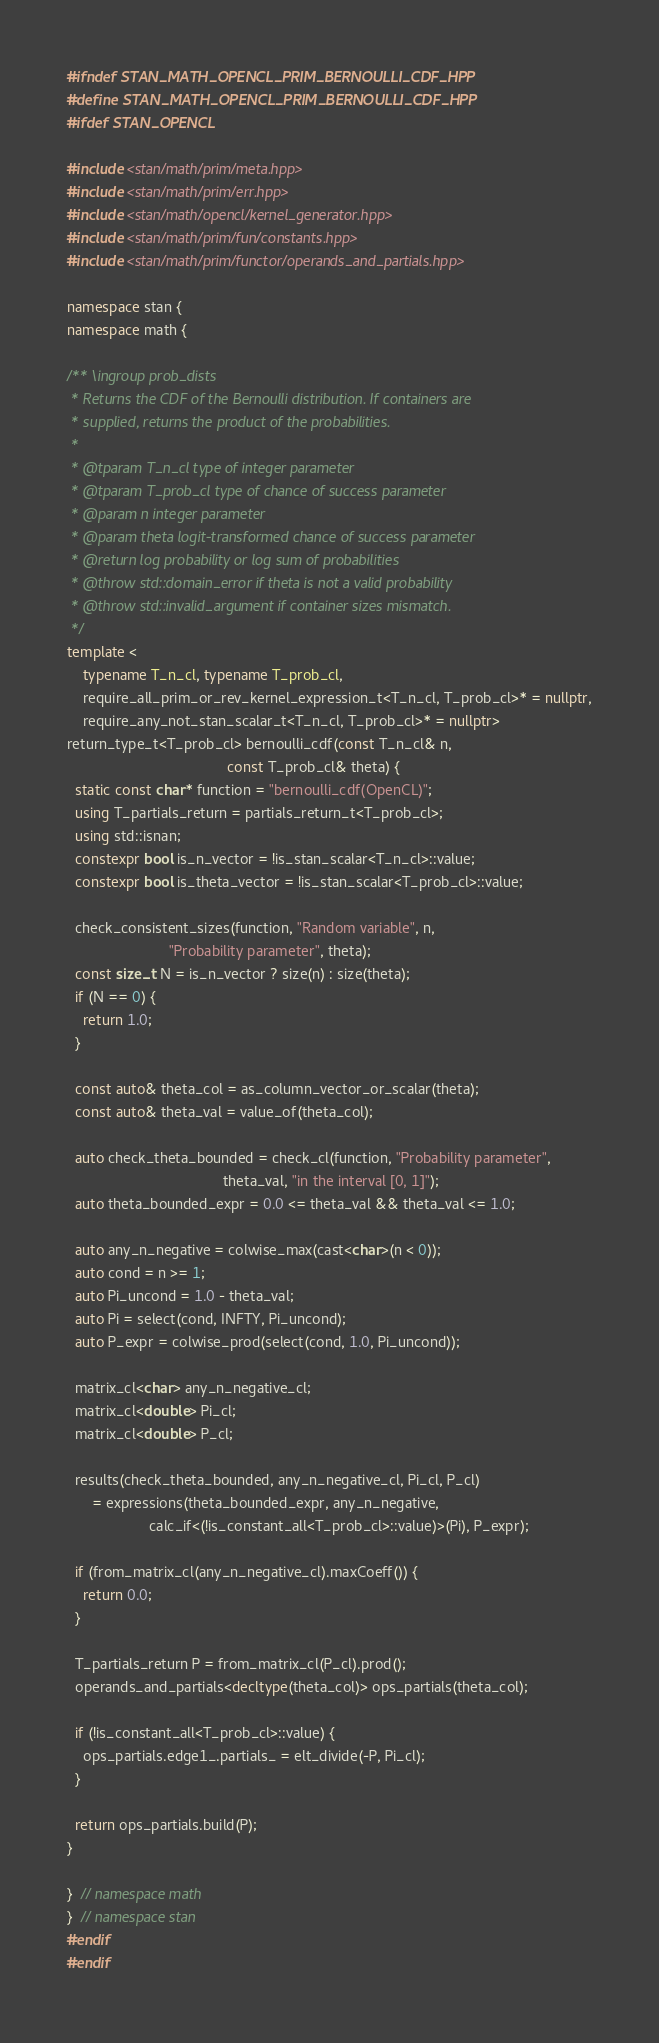Convert code to text. <code><loc_0><loc_0><loc_500><loc_500><_C++_>#ifndef STAN_MATH_OPENCL_PRIM_BERNOULLI_CDF_HPP
#define STAN_MATH_OPENCL_PRIM_BERNOULLI_CDF_HPP
#ifdef STAN_OPENCL

#include <stan/math/prim/meta.hpp>
#include <stan/math/prim/err.hpp>
#include <stan/math/opencl/kernel_generator.hpp>
#include <stan/math/prim/fun/constants.hpp>
#include <stan/math/prim/functor/operands_and_partials.hpp>

namespace stan {
namespace math {

/** \ingroup prob_dists
 * Returns the CDF of the Bernoulli distribution. If containers are
 * supplied, returns the product of the probabilities.
 *
 * @tparam T_n_cl type of integer parameter
 * @tparam T_prob_cl type of chance of success parameter
 * @param n integer parameter
 * @param theta logit-transformed chance of success parameter
 * @return log probability or log sum of probabilities
 * @throw std::domain_error if theta is not a valid probability
 * @throw std::invalid_argument if container sizes mismatch.
 */
template <
    typename T_n_cl, typename T_prob_cl,
    require_all_prim_or_rev_kernel_expression_t<T_n_cl, T_prob_cl>* = nullptr,
    require_any_not_stan_scalar_t<T_n_cl, T_prob_cl>* = nullptr>
return_type_t<T_prob_cl> bernoulli_cdf(const T_n_cl& n,
                                       const T_prob_cl& theta) {
  static const char* function = "bernoulli_cdf(OpenCL)";
  using T_partials_return = partials_return_t<T_prob_cl>;
  using std::isnan;
  constexpr bool is_n_vector = !is_stan_scalar<T_n_cl>::value;
  constexpr bool is_theta_vector = !is_stan_scalar<T_prob_cl>::value;

  check_consistent_sizes(function, "Random variable", n,
                         "Probability parameter", theta);
  const size_t N = is_n_vector ? size(n) : size(theta);
  if (N == 0) {
    return 1.0;
  }

  const auto& theta_col = as_column_vector_or_scalar(theta);
  const auto& theta_val = value_of(theta_col);

  auto check_theta_bounded = check_cl(function, "Probability parameter",
                                      theta_val, "in the interval [0, 1]");
  auto theta_bounded_expr = 0.0 <= theta_val && theta_val <= 1.0;

  auto any_n_negative = colwise_max(cast<char>(n < 0));
  auto cond = n >= 1;
  auto Pi_uncond = 1.0 - theta_val;
  auto Pi = select(cond, INFTY, Pi_uncond);
  auto P_expr = colwise_prod(select(cond, 1.0, Pi_uncond));

  matrix_cl<char> any_n_negative_cl;
  matrix_cl<double> Pi_cl;
  matrix_cl<double> P_cl;

  results(check_theta_bounded, any_n_negative_cl, Pi_cl, P_cl)
      = expressions(theta_bounded_expr, any_n_negative,
                    calc_if<(!is_constant_all<T_prob_cl>::value)>(Pi), P_expr);

  if (from_matrix_cl(any_n_negative_cl).maxCoeff()) {
    return 0.0;
  }

  T_partials_return P = from_matrix_cl(P_cl).prod();
  operands_and_partials<decltype(theta_col)> ops_partials(theta_col);

  if (!is_constant_all<T_prob_cl>::value) {
    ops_partials.edge1_.partials_ = elt_divide(-P, Pi_cl);
  }

  return ops_partials.build(P);
}

}  // namespace math
}  // namespace stan
#endif
#endif
</code> 